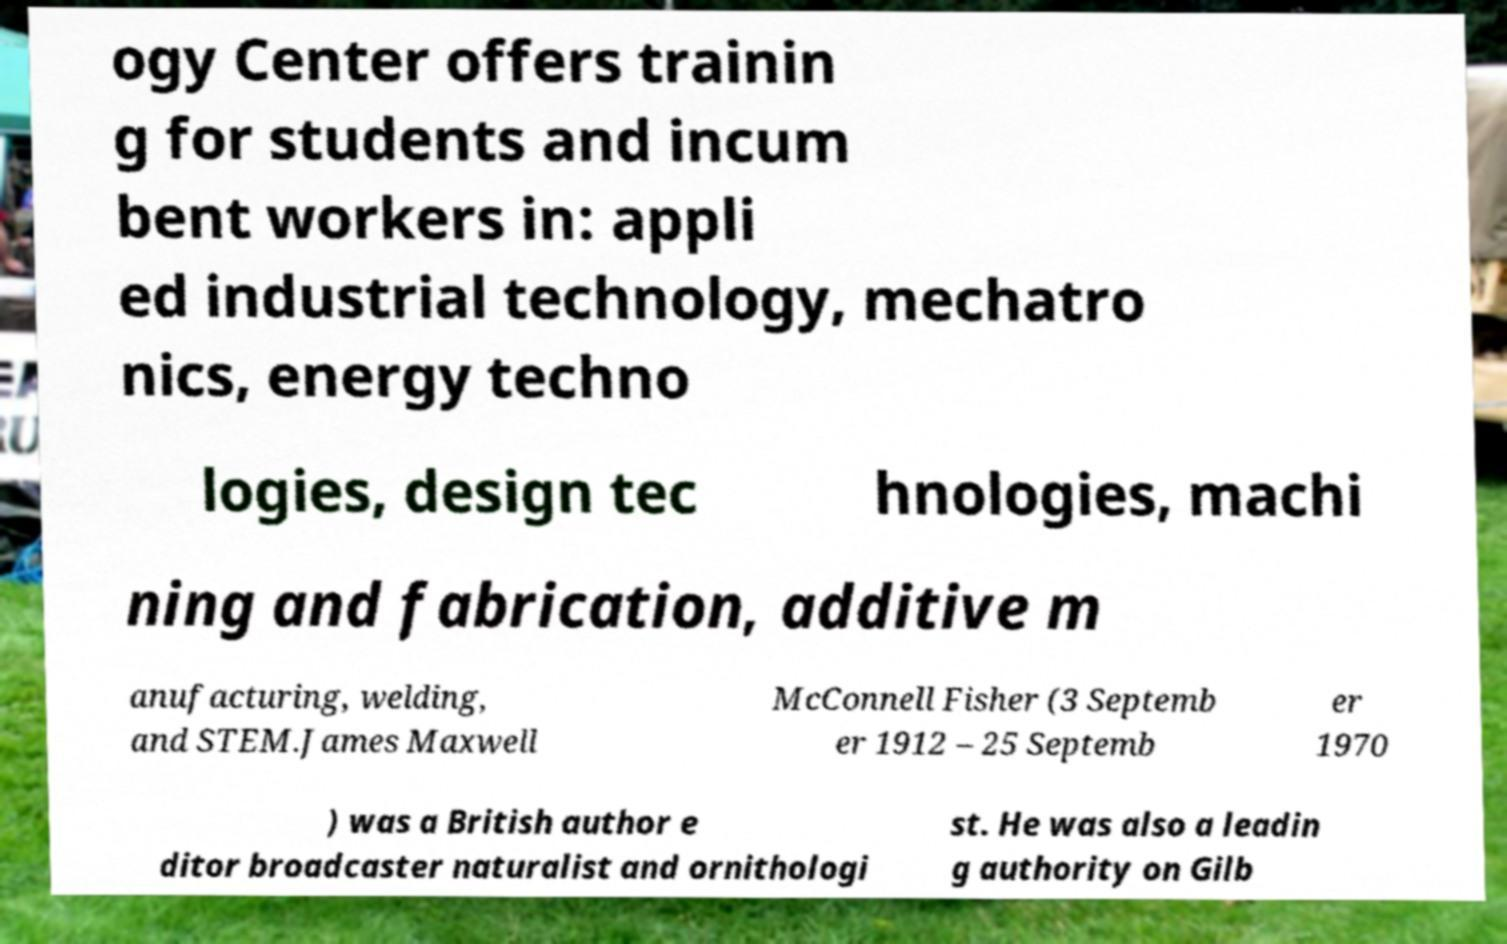For documentation purposes, I need the text within this image transcribed. Could you provide that? ogy Center offers trainin g for students and incum bent workers in: appli ed industrial technology, mechatro nics, energy techno logies, design tec hnologies, machi ning and fabrication, additive m anufacturing, welding, and STEM.James Maxwell McConnell Fisher (3 Septemb er 1912 – 25 Septemb er 1970 ) was a British author e ditor broadcaster naturalist and ornithologi st. He was also a leadin g authority on Gilb 